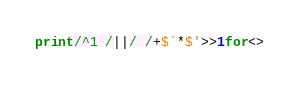<code> <loc_0><loc_0><loc_500><loc_500><_Perl_>print/^1 /||/ /+$`*$'>>1for<></code> 